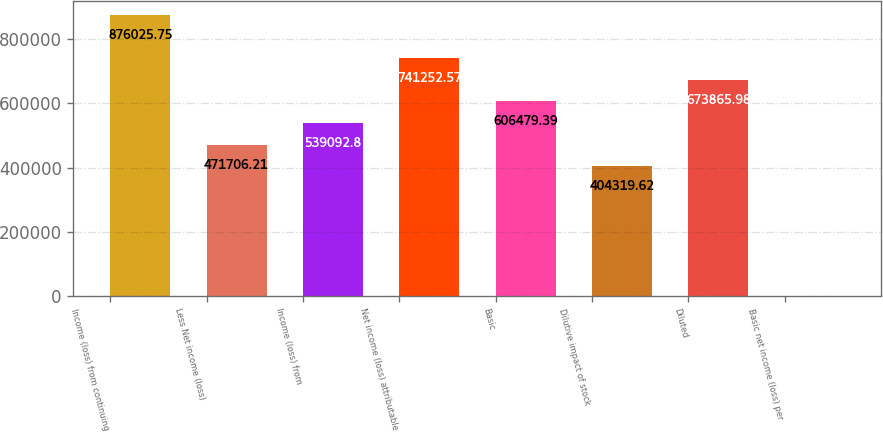Convert chart. <chart><loc_0><loc_0><loc_500><loc_500><bar_chart><fcel>Income (loss) from continuing<fcel>Less Net income (loss)<fcel>Income (loss) from<fcel>Net income (loss) attributable<fcel>Basic<fcel>Dilutive impact of stock<fcel>Diluted<fcel>Basic net income (loss) per<nl><fcel>876026<fcel>471706<fcel>539093<fcel>741253<fcel>606479<fcel>404320<fcel>673866<fcel>0.08<nl></chart> 